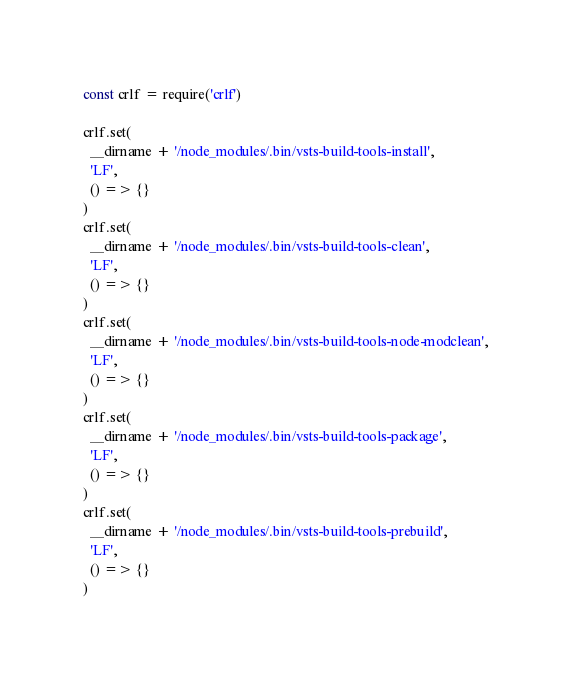Convert code to text. <code><loc_0><loc_0><loc_500><loc_500><_JavaScript_>const crlf = require('crlf')

crlf.set(
  __dirname + '/node_modules/.bin/vsts-build-tools-install',
  'LF',
  () => {}
)
crlf.set(
  __dirname + '/node_modules/.bin/vsts-build-tools-clean',
  'LF',
  () => {}
)
crlf.set(
  __dirname + '/node_modules/.bin/vsts-build-tools-node-modclean',
  'LF',
  () => {}
)
crlf.set(
  __dirname + '/node_modules/.bin/vsts-build-tools-package',
  'LF',
  () => {}
)
crlf.set(
  __dirname + '/node_modules/.bin/vsts-build-tools-prebuild',
  'LF',
  () => {}
)
</code> 